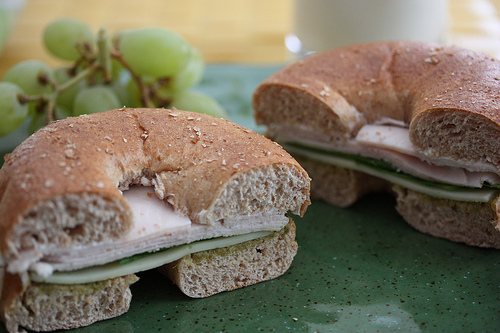<image>
Can you confirm if the table is under the grapes? Yes. The table is positioned underneath the grapes, with the grapes above it in the vertical space. 